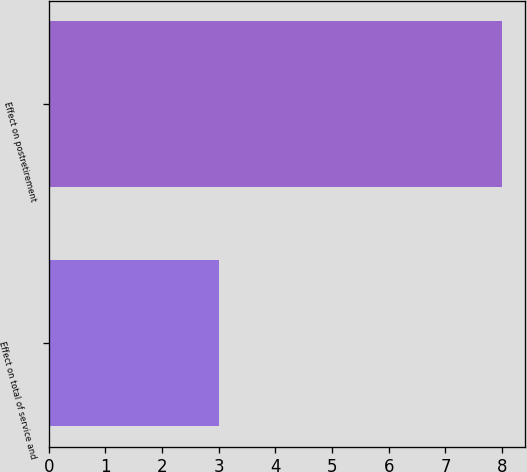Convert chart to OTSL. <chart><loc_0><loc_0><loc_500><loc_500><bar_chart><fcel>Effect on total of service and<fcel>Effect on postretirement<nl><fcel>3<fcel>8<nl></chart> 